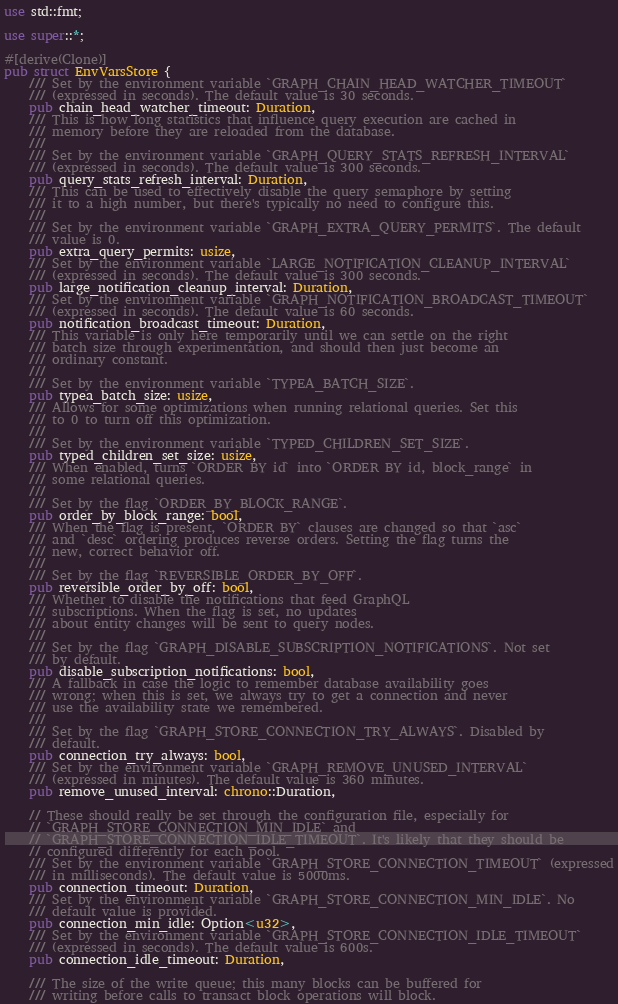Convert code to text. <code><loc_0><loc_0><loc_500><loc_500><_Rust_>use std::fmt;

use super::*;

#[derive(Clone)]
pub struct EnvVarsStore {
    /// Set by the environment variable `GRAPH_CHAIN_HEAD_WATCHER_TIMEOUT`
    /// (expressed in seconds). The default value is 30 seconds.
    pub chain_head_watcher_timeout: Duration,
    /// This is how long statistics that influence query execution are cached in
    /// memory before they are reloaded from the database.
    ///
    /// Set by the environment variable `GRAPH_QUERY_STATS_REFRESH_INTERVAL`
    /// (expressed in seconds). The default value is 300 seconds.
    pub query_stats_refresh_interval: Duration,
    /// This can be used to effectively disable the query semaphore by setting
    /// it to a high number, but there's typically no need to configure this.
    ///
    /// Set by the environment variable `GRAPH_EXTRA_QUERY_PERMITS`. The default
    /// value is 0.
    pub extra_query_permits: usize,
    /// Set by the environment variable `LARGE_NOTIFICATION_CLEANUP_INTERVAL`
    /// (expressed in seconds). The default value is 300 seconds.
    pub large_notification_cleanup_interval: Duration,
    /// Set by the environment variable `GRAPH_NOTIFICATION_BROADCAST_TIMEOUT`
    /// (expressed in seconds). The default value is 60 seconds.
    pub notification_broadcast_timeout: Duration,
    /// This variable is only here temporarily until we can settle on the right
    /// batch size through experimentation, and should then just become an
    /// ordinary constant.
    ///
    /// Set by the environment variable `TYPEA_BATCH_SIZE`.
    pub typea_batch_size: usize,
    /// Allows for some optimizations when running relational queries. Set this
    /// to 0 to turn off this optimization.
    ///
    /// Set by the environment variable `TYPED_CHILDREN_SET_SIZE`.
    pub typed_children_set_size: usize,
    /// When enabled, turns `ORDER BY id` into `ORDER BY id, block_range` in
    /// some relational queries.
    ///
    /// Set by the flag `ORDER_BY_BLOCK_RANGE`.
    pub order_by_block_range: bool,
    /// When the flag is present, `ORDER BY` clauses are changed so that `asc`
    /// and `desc` ordering produces reverse orders. Setting the flag turns the
    /// new, correct behavior off.
    ///
    /// Set by the flag `REVERSIBLE_ORDER_BY_OFF`.
    pub reversible_order_by_off: bool,
    /// Whether to disable the notifications that feed GraphQL
    /// subscriptions. When the flag is set, no updates
    /// about entity changes will be sent to query nodes.
    ///
    /// Set by the flag `GRAPH_DISABLE_SUBSCRIPTION_NOTIFICATIONS`. Not set
    /// by default.
    pub disable_subscription_notifications: bool,
    /// A fallback in case the logic to remember database availability goes
    /// wrong; when this is set, we always try to get a connection and never
    /// use the availability state we remembered.
    ///
    /// Set by the flag `GRAPH_STORE_CONNECTION_TRY_ALWAYS`. Disabled by
    /// default.
    pub connection_try_always: bool,
    /// Set by the environment variable `GRAPH_REMOVE_UNUSED_INTERVAL`
    /// (expressed in minutes). The default value is 360 minutes.
    pub remove_unused_interval: chrono::Duration,

    // These should really be set through the configuration file, especially for
    // `GRAPH_STORE_CONNECTION_MIN_IDLE` and
    // `GRAPH_STORE_CONNECTION_IDLE_TIMEOUT`. It's likely that they should be
    // configured differently for each pool.
    /// Set by the environment variable `GRAPH_STORE_CONNECTION_TIMEOUT` (expressed
    /// in milliseconds). The default value is 5000ms.
    pub connection_timeout: Duration,
    /// Set by the environment variable `GRAPH_STORE_CONNECTION_MIN_IDLE`. No
    /// default value is provided.
    pub connection_min_idle: Option<u32>,
    /// Set by the environment variable `GRAPH_STORE_CONNECTION_IDLE_TIMEOUT`
    /// (expressed in seconds). The default value is 600s.
    pub connection_idle_timeout: Duration,

    /// The size of the write queue; this many blocks can be buffered for
    /// writing before calls to transact block operations will block.</code> 